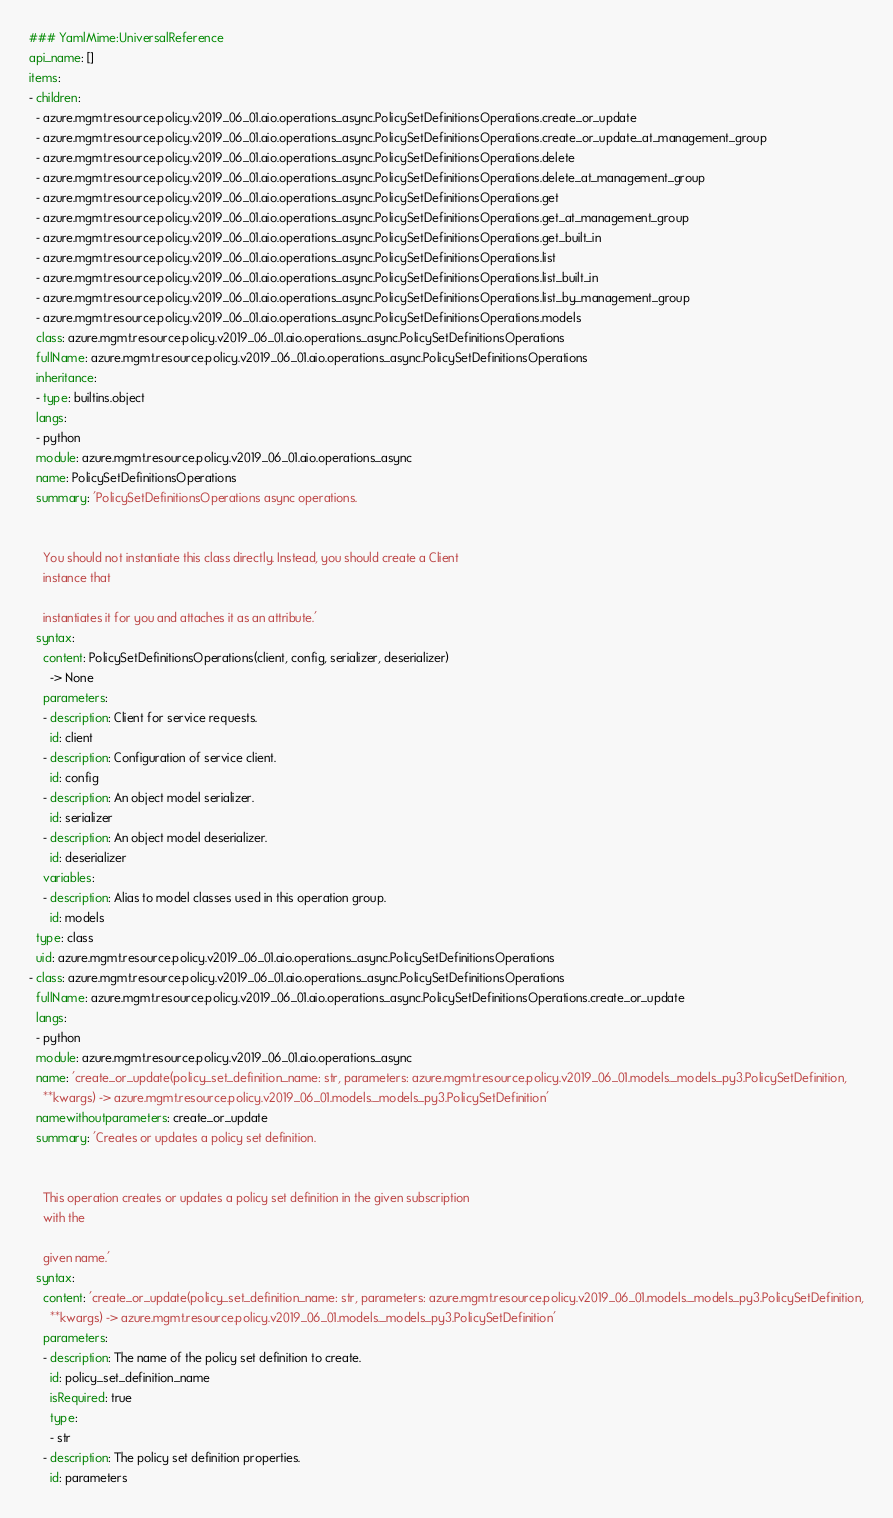<code> <loc_0><loc_0><loc_500><loc_500><_YAML_>### YamlMime:UniversalReference
api_name: []
items:
- children:
  - azure.mgmt.resource.policy.v2019_06_01.aio.operations_async.PolicySetDefinitionsOperations.create_or_update
  - azure.mgmt.resource.policy.v2019_06_01.aio.operations_async.PolicySetDefinitionsOperations.create_or_update_at_management_group
  - azure.mgmt.resource.policy.v2019_06_01.aio.operations_async.PolicySetDefinitionsOperations.delete
  - azure.mgmt.resource.policy.v2019_06_01.aio.operations_async.PolicySetDefinitionsOperations.delete_at_management_group
  - azure.mgmt.resource.policy.v2019_06_01.aio.operations_async.PolicySetDefinitionsOperations.get
  - azure.mgmt.resource.policy.v2019_06_01.aio.operations_async.PolicySetDefinitionsOperations.get_at_management_group
  - azure.mgmt.resource.policy.v2019_06_01.aio.operations_async.PolicySetDefinitionsOperations.get_built_in
  - azure.mgmt.resource.policy.v2019_06_01.aio.operations_async.PolicySetDefinitionsOperations.list
  - azure.mgmt.resource.policy.v2019_06_01.aio.operations_async.PolicySetDefinitionsOperations.list_built_in
  - azure.mgmt.resource.policy.v2019_06_01.aio.operations_async.PolicySetDefinitionsOperations.list_by_management_group
  - azure.mgmt.resource.policy.v2019_06_01.aio.operations_async.PolicySetDefinitionsOperations.models
  class: azure.mgmt.resource.policy.v2019_06_01.aio.operations_async.PolicySetDefinitionsOperations
  fullName: azure.mgmt.resource.policy.v2019_06_01.aio.operations_async.PolicySetDefinitionsOperations
  inheritance:
  - type: builtins.object
  langs:
  - python
  module: azure.mgmt.resource.policy.v2019_06_01.aio.operations_async
  name: PolicySetDefinitionsOperations
  summary: 'PolicySetDefinitionsOperations async operations.


    You should not instantiate this class directly. Instead, you should create a Client
    instance that

    instantiates it for you and attaches it as an attribute.'
  syntax:
    content: PolicySetDefinitionsOperations(client, config, serializer, deserializer)
      -> None
    parameters:
    - description: Client for service requests.
      id: client
    - description: Configuration of service client.
      id: config
    - description: An object model serializer.
      id: serializer
    - description: An object model deserializer.
      id: deserializer
    variables:
    - description: Alias to model classes used in this operation group.
      id: models
  type: class
  uid: azure.mgmt.resource.policy.v2019_06_01.aio.operations_async.PolicySetDefinitionsOperations
- class: azure.mgmt.resource.policy.v2019_06_01.aio.operations_async.PolicySetDefinitionsOperations
  fullName: azure.mgmt.resource.policy.v2019_06_01.aio.operations_async.PolicySetDefinitionsOperations.create_or_update
  langs:
  - python
  module: azure.mgmt.resource.policy.v2019_06_01.aio.operations_async
  name: 'create_or_update(policy_set_definition_name: str, parameters: azure.mgmt.resource.policy.v2019_06_01.models._models_py3.PolicySetDefinition,
    **kwargs) -> azure.mgmt.resource.policy.v2019_06_01.models._models_py3.PolicySetDefinition'
  namewithoutparameters: create_or_update
  summary: 'Creates or updates a policy set definition.


    This operation creates or updates a policy set definition in the given subscription
    with the

    given name.'
  syntax:
    content: 'create_or_update(policy_set_definition_name: str, parameters: azure.mgmt.resource.policy.v2019_06_01.models._models_py3.PolicySetDefinition,
      **kwargs) -> azure.mgmt.resource.policy.v2019_06_01.models._models_py3.PolicySetDefinition'
    parameters:
    - description: The name of the policy set definition to create.
      id: policy_set_definition_name
      isRequired: true
      type:
      - str
    - description: The policy set definition properties.
      id: parameters</code> 